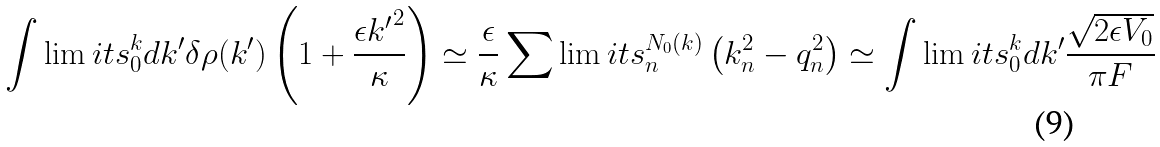Convert formula to latex. <formula><loc_0><loc_0><loc_500><loc_500>\int \lim i t s _ { 0 } ^ { k } d k ^ { \prime } \delta \rho ( k ^ { \prime } ) \left ( 1 + \frac { \epsilon { k ^ { \prime } } ^ { 2 } } { \kappa } \right ) \simeq \frac { \epsilon } { \kappa } \sum \lim i t s _ { n } ^ { N _ { 0 } ( k ) } \left ( k _ { n } ^ { 2 } - q _ { n } ^ { 2 } \right ) \simeq \int \lim i t s _ { 0 } ^ { k } d k ^ { \prime } \frac { \sqrt { { 2 \epsilon V _ { 0 } } } } { \pi F }</formula> 